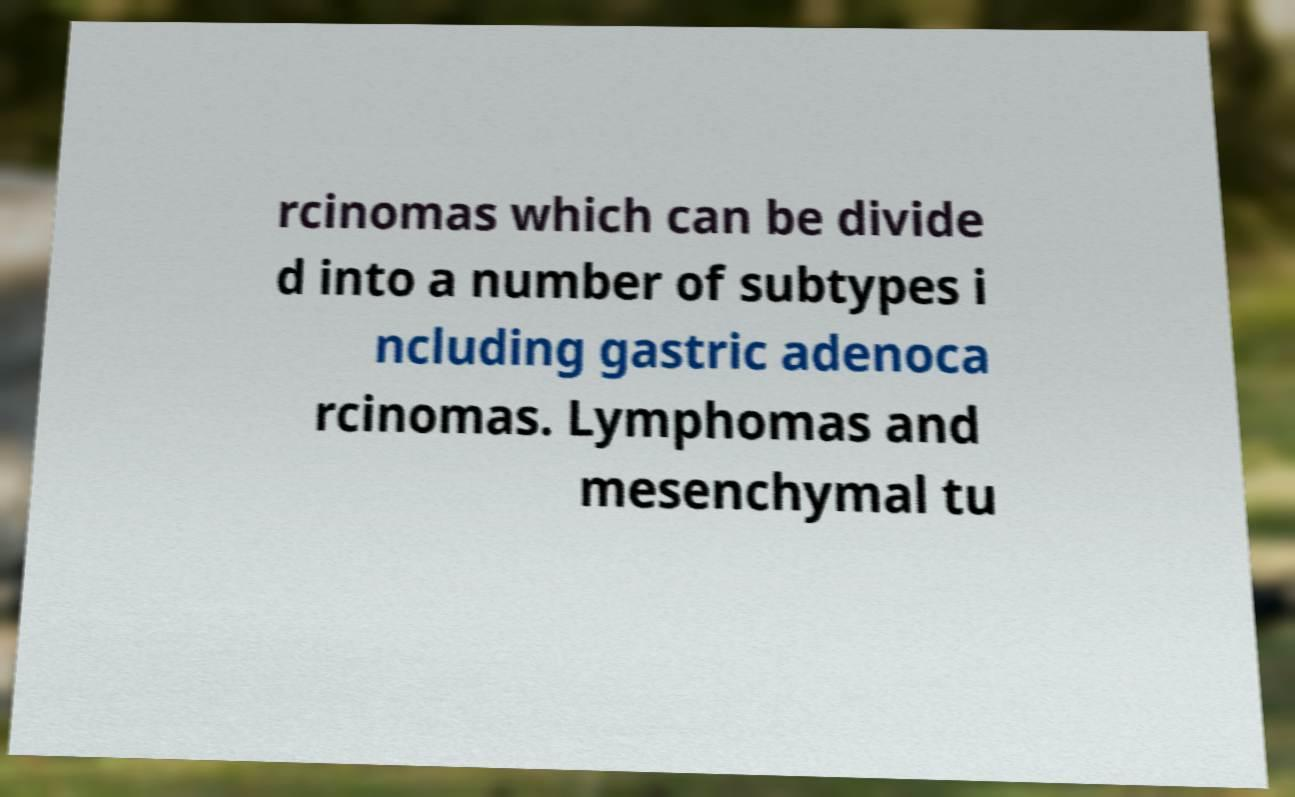What messages or text are displayed in this image? I need them in a readable, typed format. rcinomas which can be divide d into a number of subtypes i ncluding gastric adenoca rcinomas. Lymphomas and mesenchymal tu 